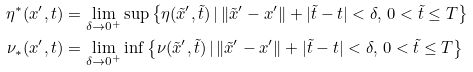Convert formula to latex. <formula><loc_0><loc_0><loc_500><loc_500>\eta ^ { * } ( x ^ { \prime } , t ) & = \lim _ { \delta \to 0 ^ { + } } \sup \left \{ \eta ( \tilde { x } ^ { \prime } , \tilde { t } ) \, | \, \| \tilde { x } ^ { \prime } - x ^ { \prime } \| + | \tilde { t } - t | < \delta , \, 0 < \tilde { t } \leq T \right \} \\ \nu _ { * } ( x ^ { \prime } , t ) & = \lim _ { \delta \to 0 ^ { + } } \inf \left \{ \nu ( \tilde { x } ^ { \prime } , \tilde { t } ) \, | \, \| \tilde { x } ^ { \prime } - x ^ { \prime } \| + | \tilde { t } - t | < \delta , \, 0 < \tilde { t } \leq T \right \}</formula> 